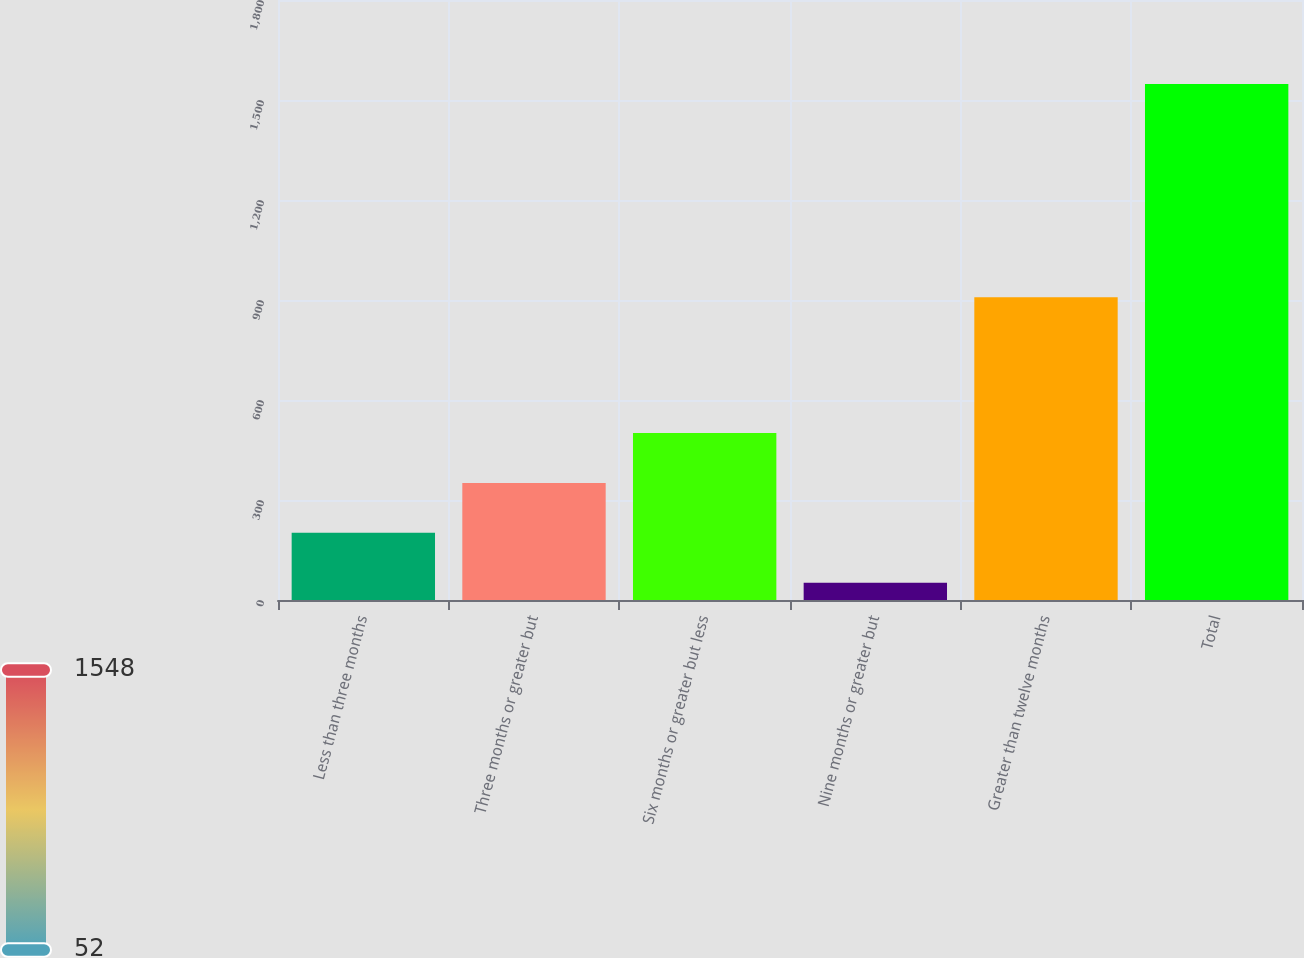<chart> <loc_0><loc_0><loc_500><loc_500><bar_chart><fcel>Less than three months<fcel>Three months or greater but<fcel>Six months or greater but less<fcel>Nine months or greater but<fcel>Greater than twelve months<fcel>Total<nl><fcel>201.6<fcel>351.2<fcel>500.8<fcel>52<fcel>908<fcel>1548<nl></chart> 